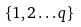Convert formula to latex. <formula><loc_0><loc_0><loc_500><loc_500>\{ 1 , 2 \dots q \}</formula> 